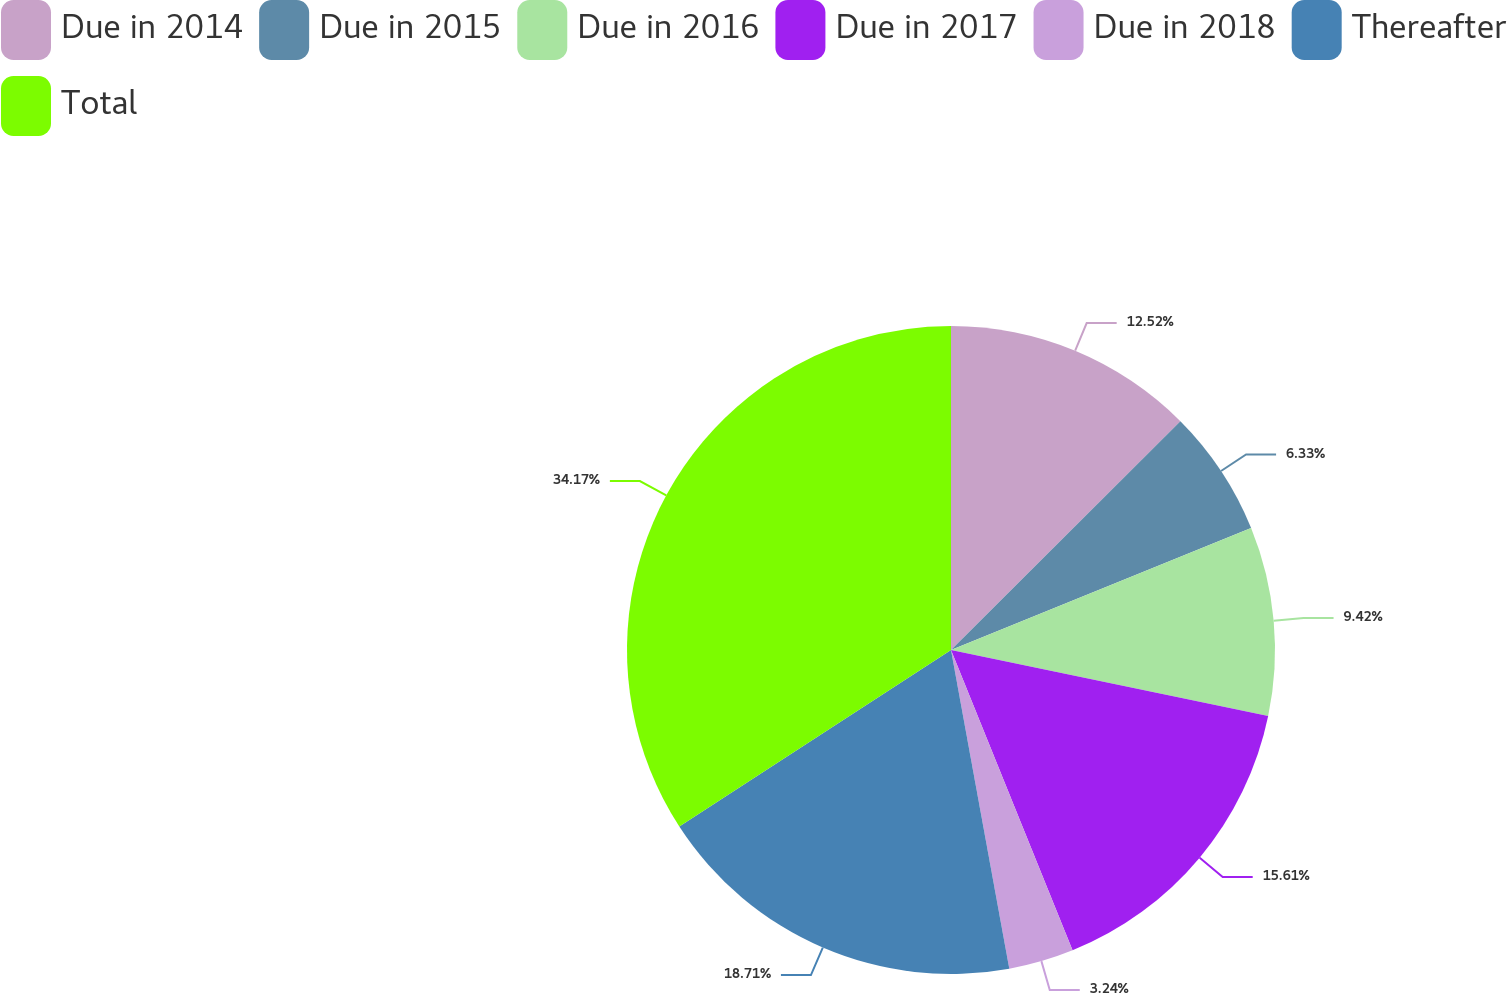<chart> <loc_0><loc_0><loc_500><loc_500><pie_chart><fcel>Due in 2014<fcel>Due in 2015<fcel>Due in 2016<fcel>Due in 2017<fcel>Due in 2018<fcel>Thereafter<fcel>Total<nl><fcel>12.52%<fcel>6.33%<fcel>9.42%<fcel>15.61%<fcel>3.24%<fcel>18.71%<fcel>34.17%<nl></chart> 